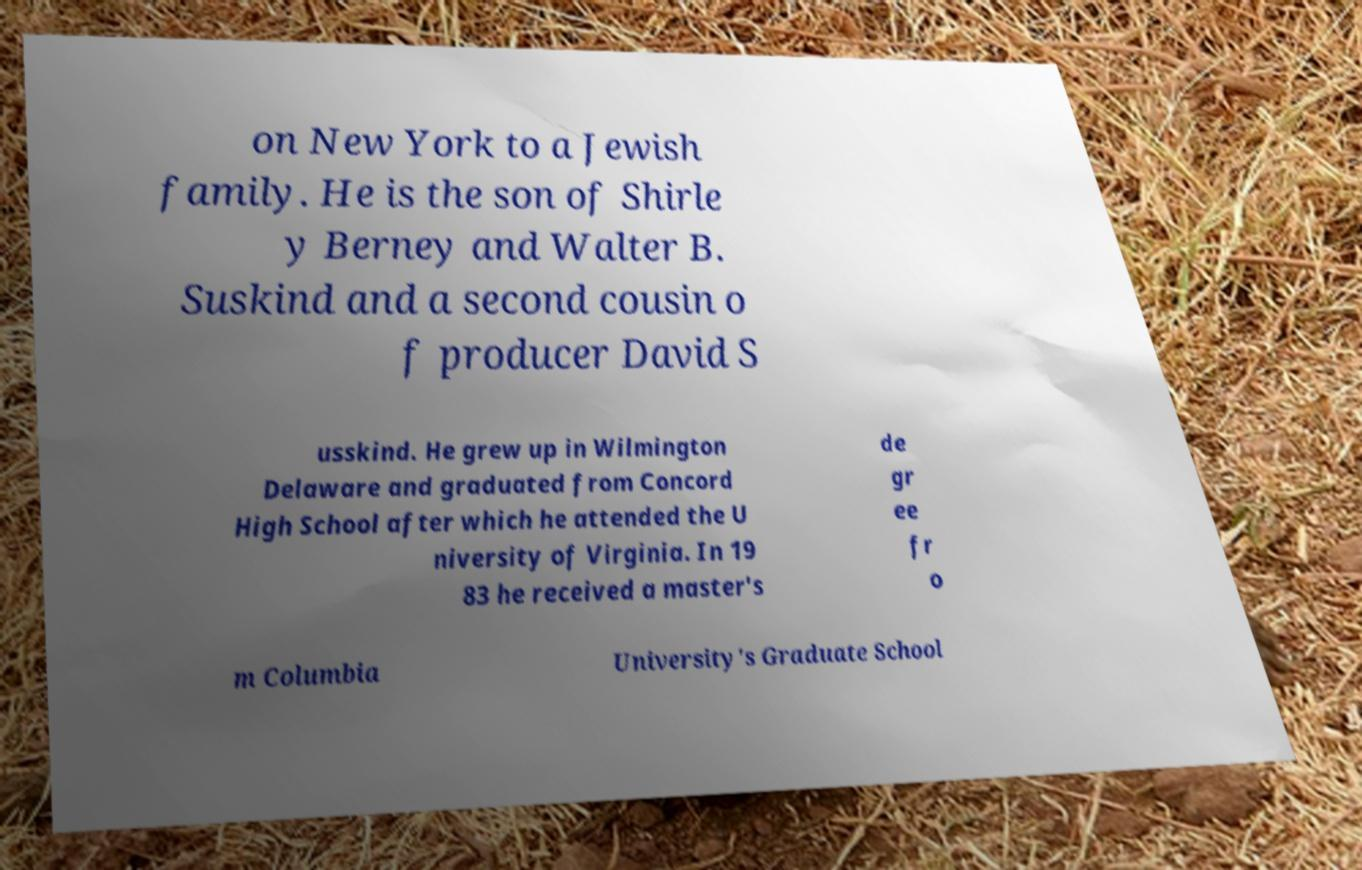Please identify and transcribe the text found in this image. on New York to a Jewish family. He is the son of Shirle y Berney and Walter B. Suskind and a second cousin o f producer David S usskind. He grew up in Wilmington Delaware and graduated from Concord High School after which he attended the U niversity of Virginia. In 19 83 he received a master's de gr ee fr o m Columbia University's Graduate School 